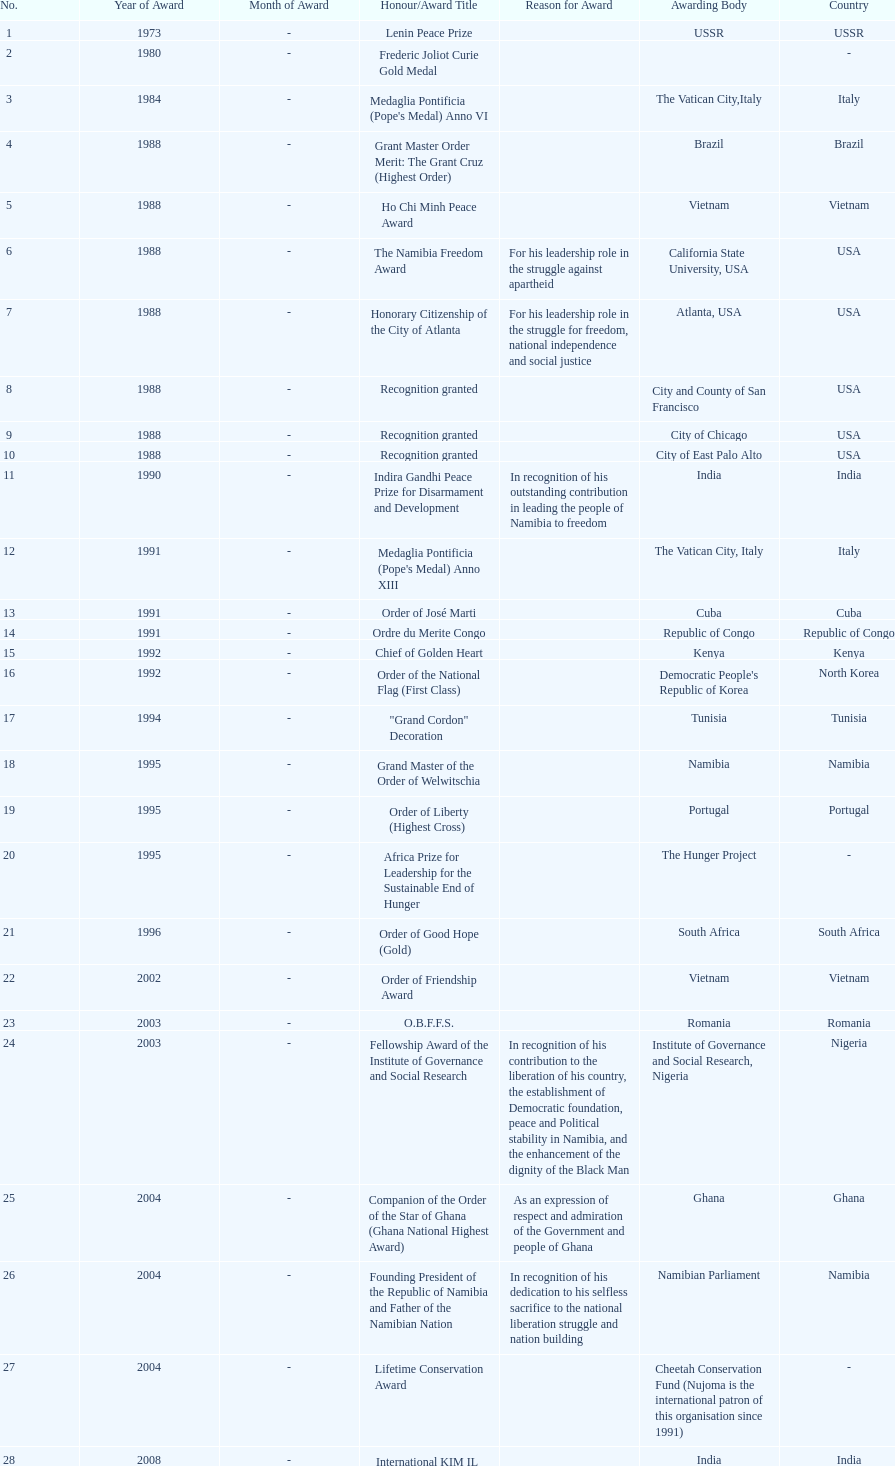The "fellowship award of the institute of governance and social research" was awarded in 2003 or 2004? 2003. 